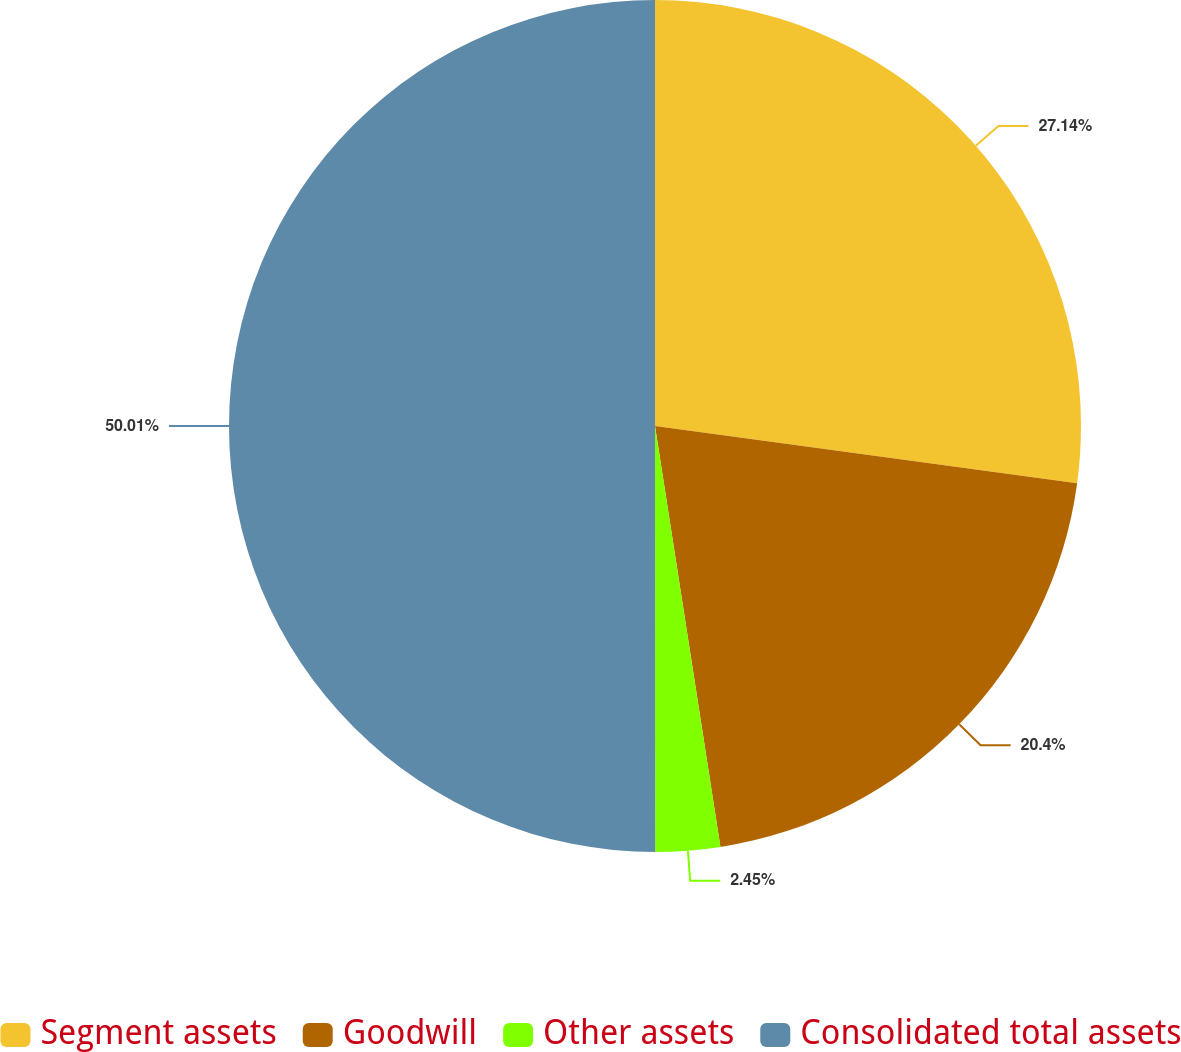<chart> <loc_0><loc_0><loc_500><loc_500><pie_chart><fcel>Segment assets<fcel>Goodwill<fcel>Other assets<fcel>Consolidated total assets<nl><fcel>27.14%<fcel>20.4%<fcel>2.45%<fcel>50.0%<nl></chart> 